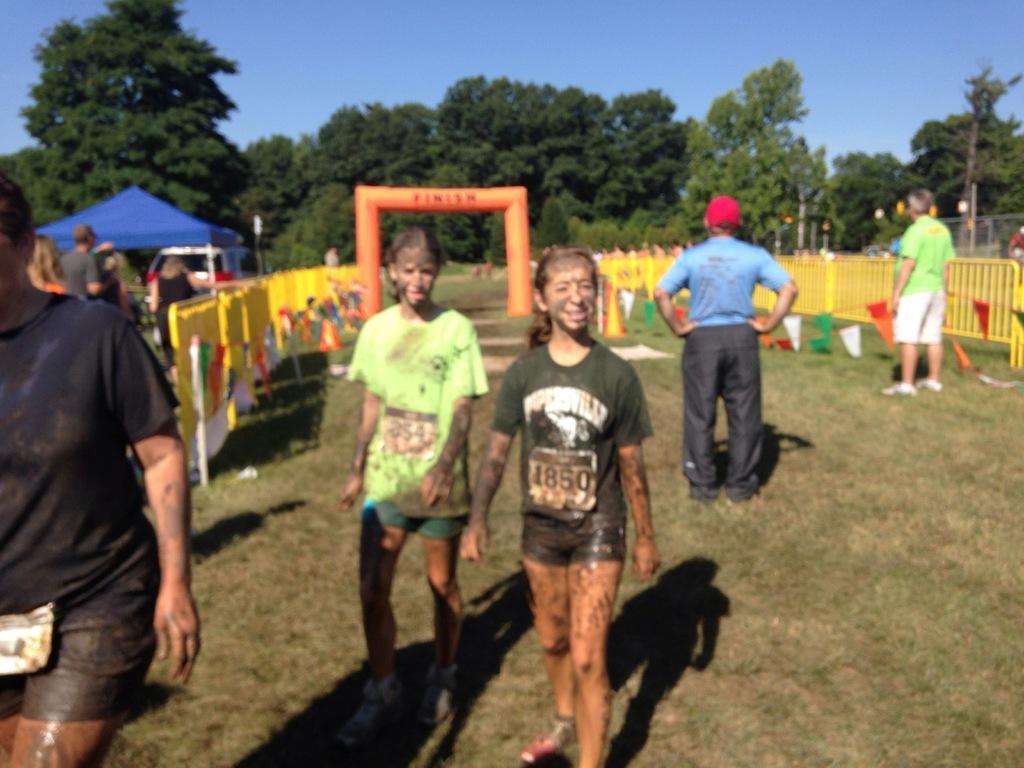Can you describe this image briefly? In this image two women are walking on the grassland. Left side there is a person walking on the grassland. Behind him there are few persons standing. Beside them there is a fence. Behind the fence there is a tent. Right side two persons are standing on the grassland having a fence. Behind the fence there are are few persons. Background there are few trees. Top of the image there is sky. 